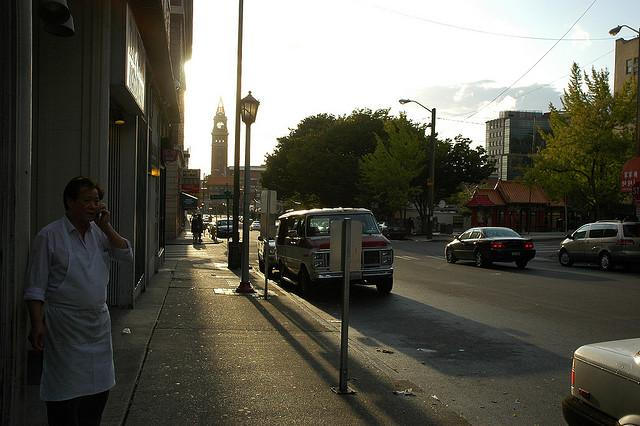What is the man in white apron holding to his ear?

Choices:
A) cellphone
B) banana
C) bean bag
D) ice pack cellphone 